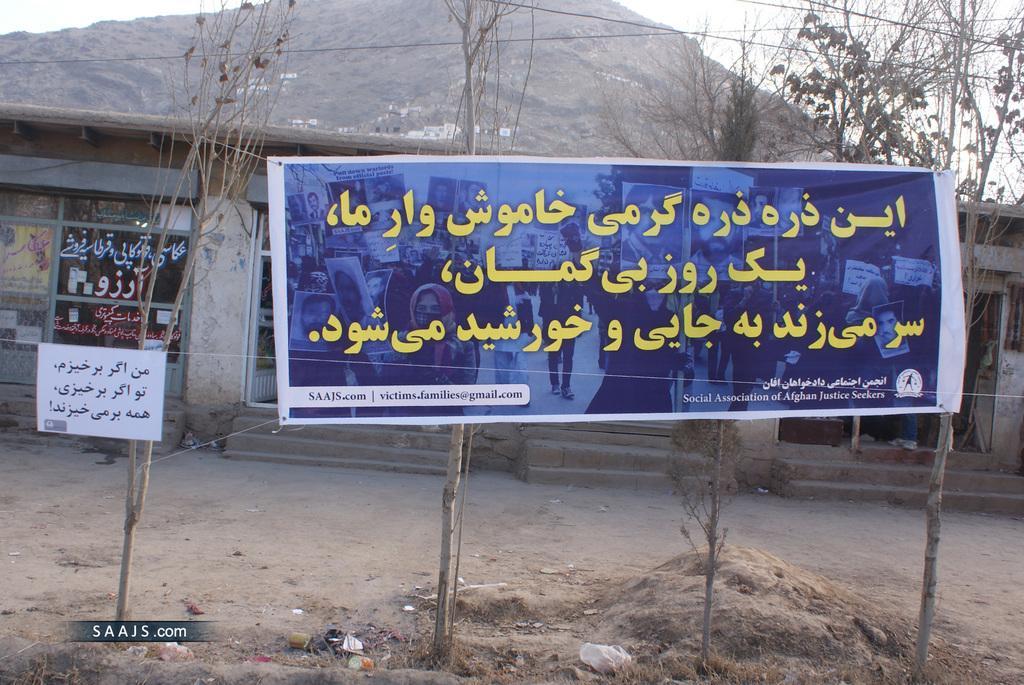Could you give a brief overview of what you see in this image? In this image I can see the ground, few trees and a banner which is blue, yellow and white in color to the trees. In the background I can see few buildings, few stairs, a mountain and the sky. 